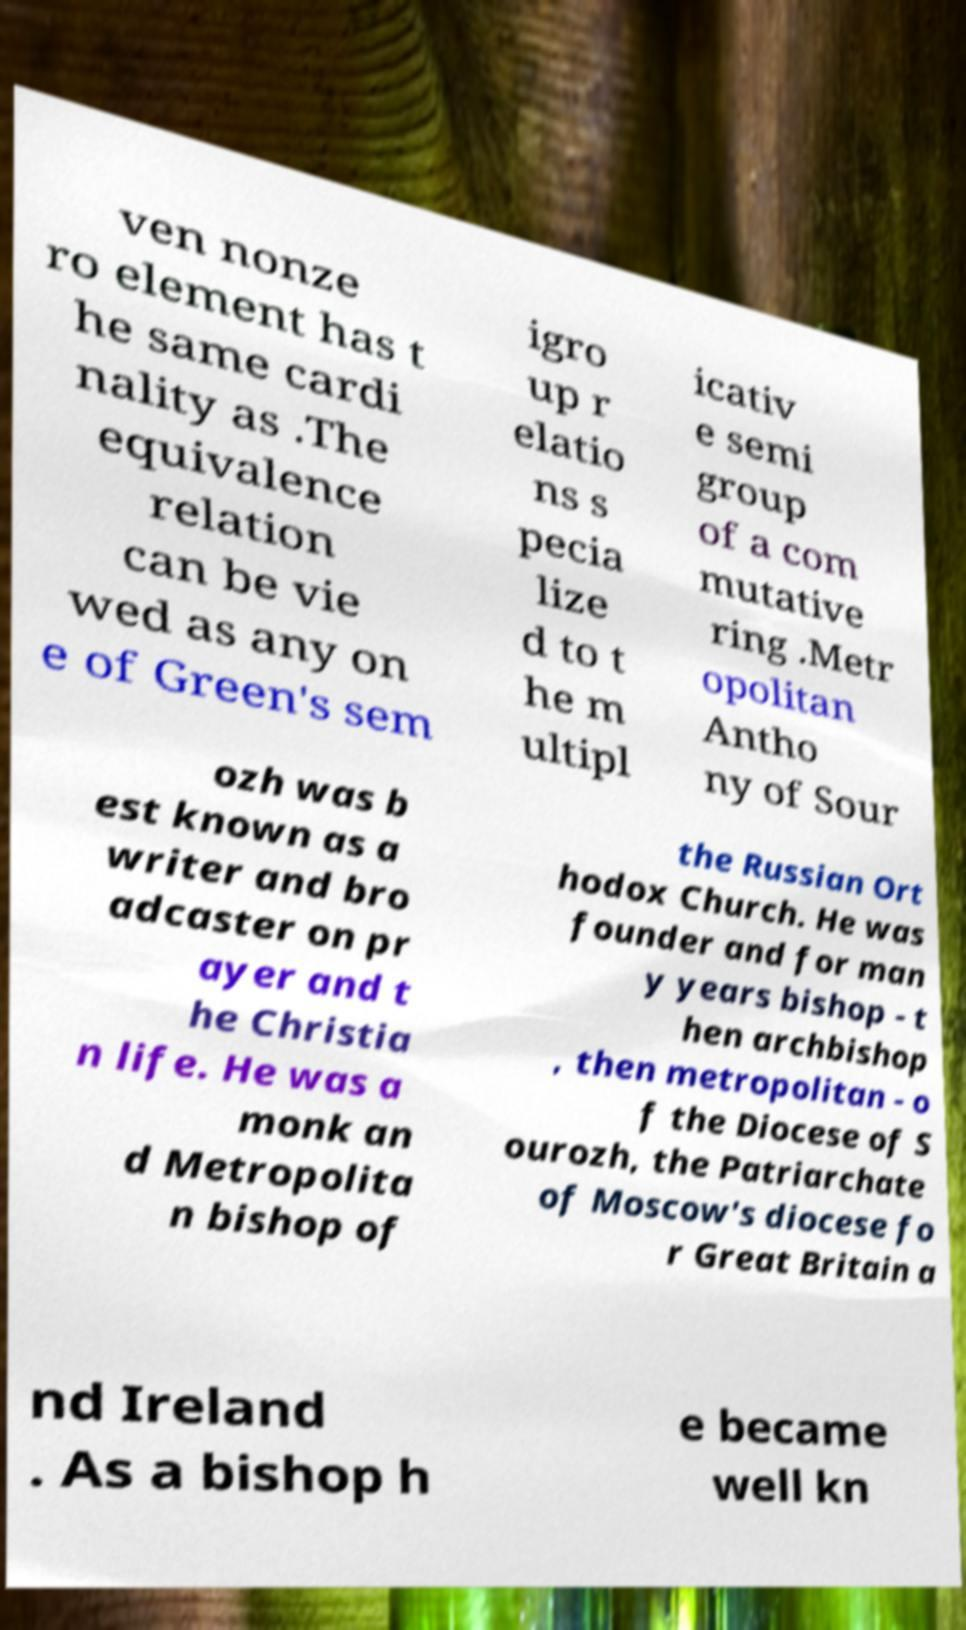Could you extract and type out the text from this image? ven nonze ro element has t he same cardi nality as .The equivalence relation can be vie wed as any on e of Green's sem igro up r elatio ns s pecia lize d to t he m ultipl icativ e semi group of a com mutative ring .Metr opolitan Antho ny of Sour ozh was b est known as a writer and bro adcaster on pr ayer and t he Christia n life. He was a monk an d Metropolita n bishop of the Russian Ort hodox Church. He was founder and for man y years bishop - t hen archbishop , then metropolitan - o f the Diocese of S ourozh, the Patriarchate of Moscow's diocese fo r Great Britain a nd Ireland . As a bishop h e became well kn 